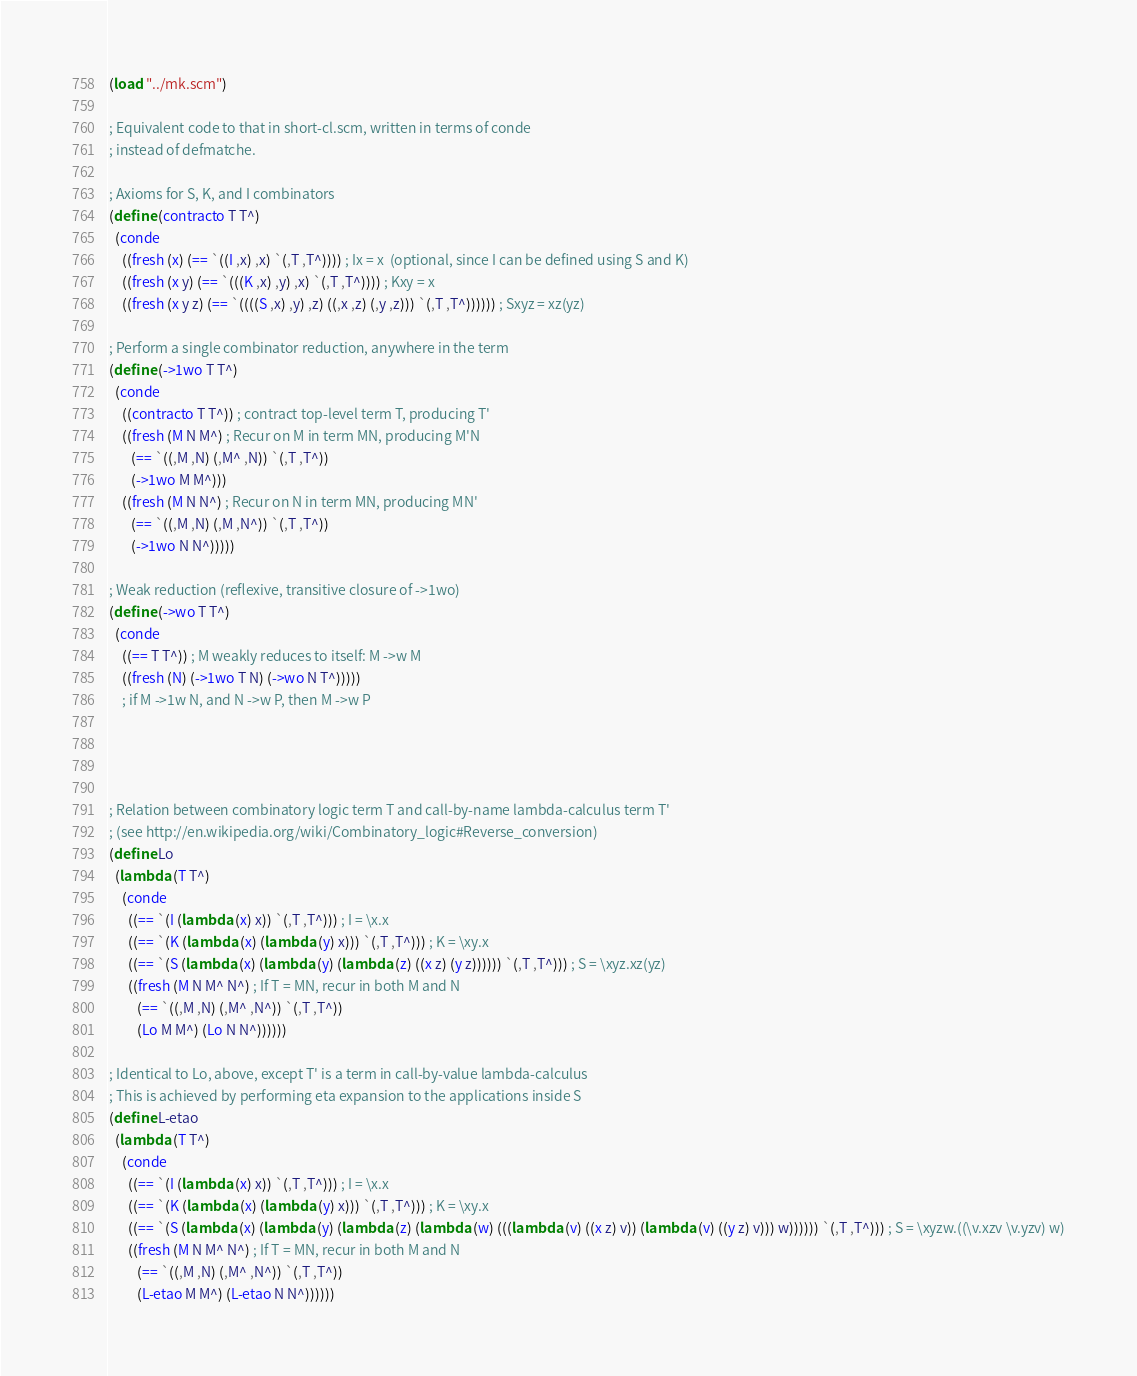Convert code to text. <code><loc_0><loc_0><loc_500><loc_500><_Scheme_>(load "../mk.scm")

; Equivalent code to that in short-cl.scm, written in terms of conde
; instead of defmatche.

; Axioms for S, K, and I combinators
(define (contracto T T^)
  (conde
    ((fresh (x) (== `((I ,x) ,x) `(,T ,T^)))) ; Ix = x  (optional, since I can be defined using S and K)
    ((fresh (x y) (== `(((K ,x) ,y) ,x) `(,T ,T^)))) ; Kxy = x
    ((fresh (x y z) (== `((((S ,x) ,y) ,z) ((,x ,z) (,y ,z))) `(,T ,T^)))))) ; Sxyz = xz(yz)

; Perform a single combinator reduction, anywhere in the term
(define (->1wo T T^)
  (conde
    ((contracto T T^)) ; contract top-level term T, producing T'
    ((fresh (M N M^) ; Recur on M in term MN, producing M'N
       (== `((,M ,N) (,M^ ,N)) `(,T ,T^))
       (->1wo M M^)))
    ((fresh (M N N^) ; Recur on N in term MN, producing MN' 
       (== `((,M ,N) (,M ,N^)) `(,T ,T^))
       (->1wo N N^)))))

; Weak reduction (reflexive, transitive closure of ->1wo)
(define (->wo T T^)
  (conde
    ((== T T^)) ; M weakly reduces to itself: M ->w M
    ((fresh (N) (->1wo T N) (->wo N T^)))))
    ; if M ->1w N, and N ->w P, then M ->w P




; Relation between combinatory logic term T and call-by-name lambda-calculus term T'
; (see http://en.wikipedia.org/wiki/Combinatory_logic#Reverse_conversion)
(define Lo
  (lambda (T T^)
    (conde
      ((== `(I (lambda (x) x)) `(,T ,T^))) ; I = \x.x
      ((== `(K (lambda (x) (lambda (y) x))) `(,T ,T^))) ; K = \xy.x
      ((== `(S (lambda (x) (lambda (y) (lambda (z) ((x z) (y z)))))) `(,T ,T^))) ; S = \xyz.xz(yz)
      ((fresh (M N M^ N^) ; If T = MN, recur in both M and N
         (== `((,M ,N) (,M^ ,N^)) `(,T ,T^))
         (Lo M M^) (Lo N N^))))))

; Identical to Lo, above, except T' is a term in call-by-value lambda-calculus
; This is achieved by performing eta expansion to the applications inside S
(define L-etao
  (lambda (T T^)
    (conde
      ((== `(I (lambda (x) x)) `(,T ,T^))) ; I = \x.x
      ((== `(K (lambda (x) (lambda (y) x))) `(,T ,T^))) ; K = \xy.x
      ((== `(S (lambda (x) (lambda (y) (lambda (z) (lambda (w) (((lambda (v) ((x z) v)) (lambda (v) ((y z) v))) w)))))) `(,T ,T^))) ; S = \xyzw.((\v.xzv \v.yzv) w)
      ((fresh (M N M^ N^) ; If T = MN, recur in both M and N
         (== `((,M ,N) (,M^ ,N^)) `(,T ,T^))
         (L-etao M M^) (L-etao N N^))))))
</code> 